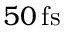<formula> <loc_0><loc_0><loc_500><loc_500>5 0 \, f s</formula> 